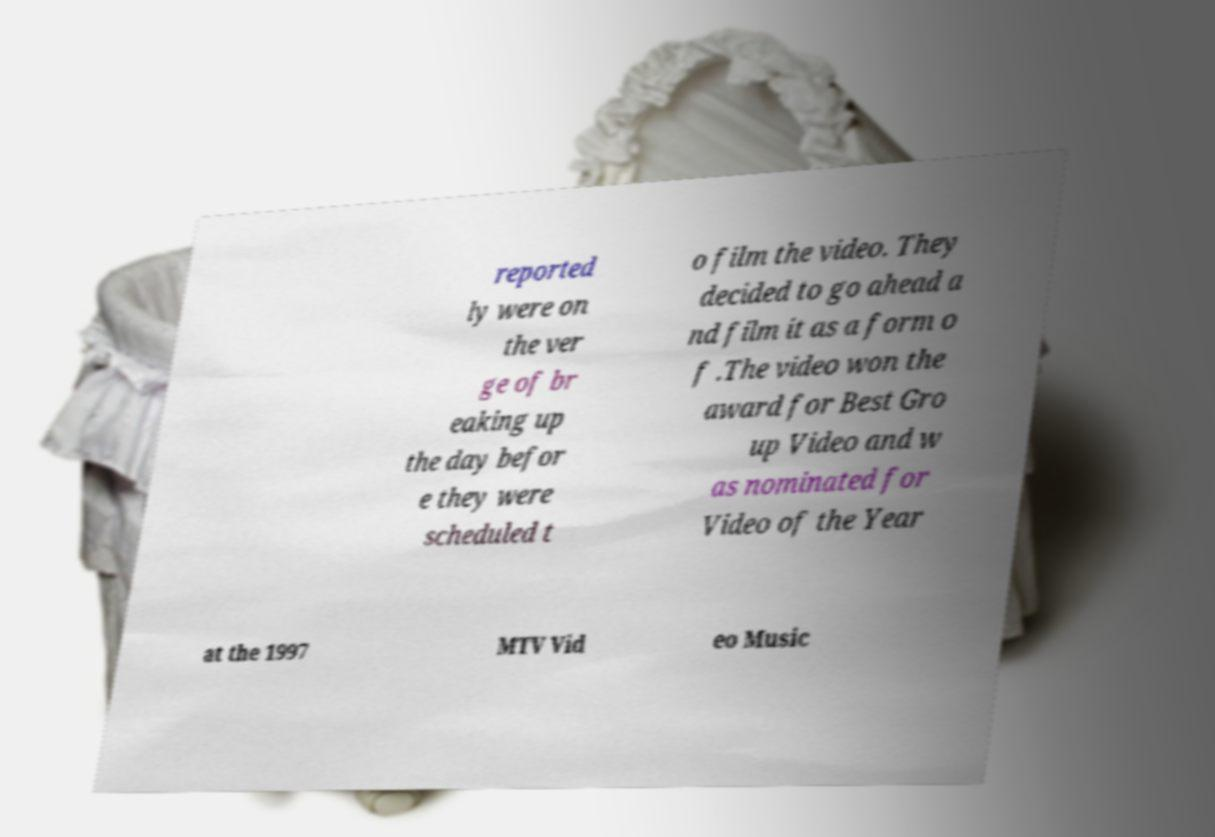Can you accurately transcribe the text from the provided image for me? reported ly were on the ver ge of br eaking up the day befor e they were scheduled t o film the video. They decided to go ahead a nd film it as a form o f .The video won the award for Best Gro up Video and w as nominated for Video of the Year at the 1997 MTV Vid eo Music 